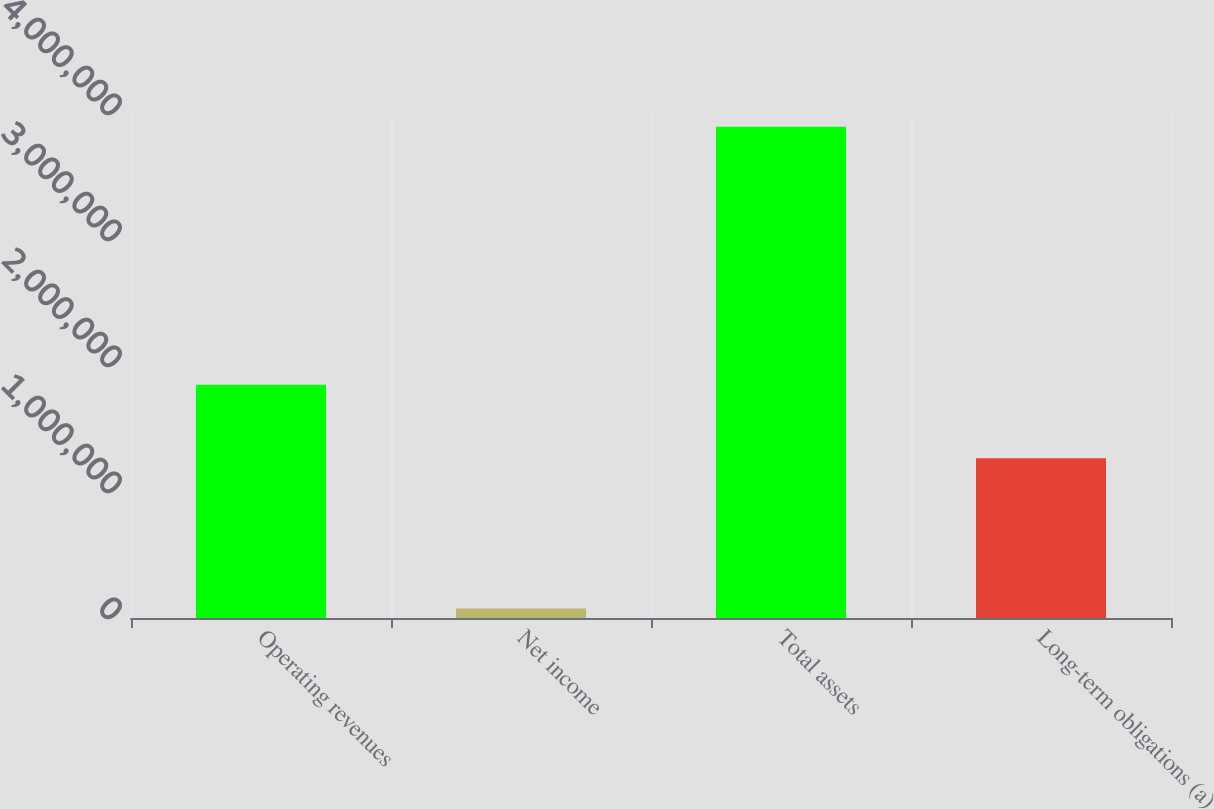Convert chart to OTSL. <chart><loc_0><loc_0><loc_500><loc_500><bar_chart><fcel>Operating revenues<fcel>Net income<fcel>Total assets<fcel>Long-term obligations (a)<nl><fcel>1.85198e+06<fcel>74804<fcel>3.89799e+06<fcel>1.26884e+06<nl></chart> 